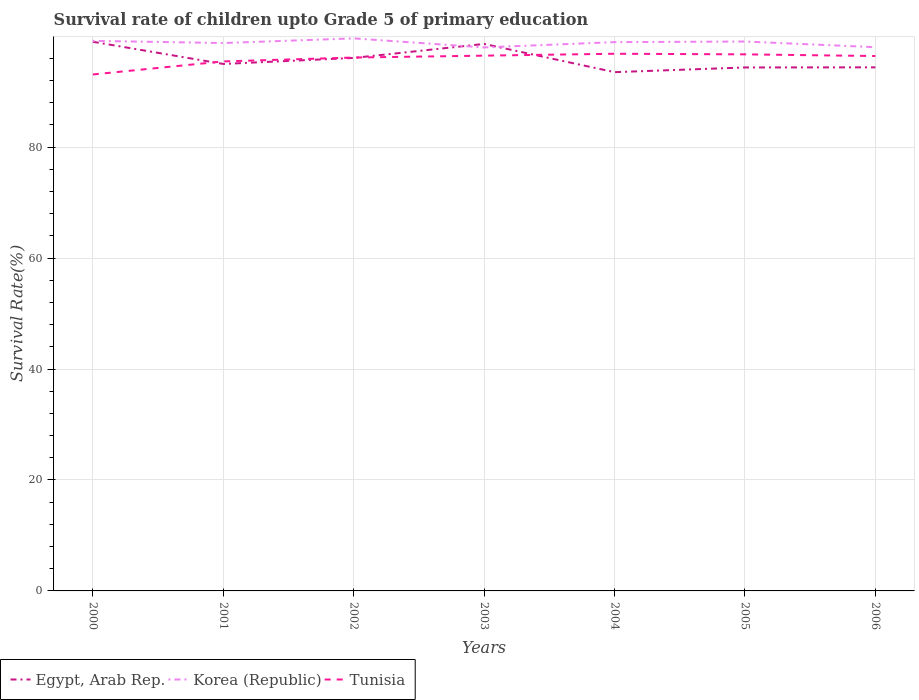Does the line corresponding to Tunisia intersect with the line corresponding to Egypt, Arab Rep.?
Give a very brief answer. Yes. Across all years, what is the maximum survival rate of children in Tunisia?
Make the answer very short. 93.1. What is the total survival rate of children in Egypt, Arab Rep. in the graph?
Make the answer very short. -0.02. What is the difference between the highest and the second highest survival rate of children in Korea (Republic)?
Ensure brevity in your answer.  1.63. What is the difference between two consecutive major ticks on the Y-axis?
Your response must be concise. 20. Does the graph contain grids?
Offer a very short reply. Yes. Where does the legend appear in the graph?
Your response must be concise. Bottom left. How many legend labels are there?
Provide a short and direct response. 3. What is the title of the graph?
Your response must be concise. Survival rate of children upto Grade 5 of primary education. What is the label or title of the Y-axis?
Offer a terse response. Survival Rate(%). What is the Survival Rate(%) of Egypt, Arab Rep. in 2000?
Your answer should be compact. 99. What is the Survival Rate(%) of Korea (Republic) in 2000?
Provide a succinct answer. 99.17. What is the Survival Rate(%) in Tunisia in 2000?
Your answer should be very brief. 93.1. What is the Survival Rate(%) of Egypt, Arab Rep. in 2001?
Provide a short and direct response. 95. What is the Survival Rate(%) of Korea (Republic) in 2001?
Give a very brief answer. 98.77. What is the Survival Rate(%) in Tunisia in 2001?
Your response must be concise. 95.46. What is the Survival Rate(%) of Egypt, Arab Rep. in 2002?
Make the answer very short. 96.09. What is the Survival Rate(%) in Korea (Republic) in 2002?
Keep it short and to the point. 99.61. What is the Survival Rate(%) in Tunisia in 2002?
Ensure brevity in your answer.  96.15. What is the Survival Rate(%) of Egypt, Arab Rep. in 2003?
Offer a terse response. 98.6. What is the Survival Rate(%) of Korea (Republic) in 2003?
Provide a short and direct response. 97.98. What is the Survival Rate(%) of Tunisia in 2003?
Keep it short and to the point. 96.49. What is the Survival Rate(%) of Egypt, Arab Rep. in 2004?
Your response must be concise. 93.52. What is the Survival Rate(%) in Korea (Republic) in 2004?
Keep it short and to the point. 98.93. What is the Survival Rate(%) in Tunisia in 2004?
Offer a terse response. 96.84. What is the Survival Rate(%) of Egypt, Arab Rep. in 2005?
Your response must be concise. 94.37. What is the Survival Rate(%) in Korea (Republic) in 2005?
Offer a very short reply. 99.04. What is the Survival Rate(%) of Tunisia in 2005?
Make the answer very short. 96.73. What is the Survival Rate(%) in Egypt, Arab Rep. in 2006?
Give a very brief answer. 94.39. What is the Survival Rate(%) in Korea (Republic) in 2006?
Give a very brief answer. 98.02. What is the Survival Rate(%) in Tunisia in 2006?
Offer a very short reply. 96.43. Across all years, what is the maximum Survival Rate(%) in Egypt, Arab Rep.?
Provide a short and direct response. 99. Across all years, what is the maximum Survival Rate(%) in Korea (Republic)?
Provide a short and direct response. 99.61. Across all years, what is the maximum Survival Rate(%) of Tunisia?
Keep it short and to the point. 96.84. Across all years, what is the minimum Survival Rate(%) of Egypt, Arab Rep.?
Keep it short and to the point. 93.52. Across all years, what is the minimum Survival Rate(%) in Korea (Republic)?
Give a very brief answer. 97.98. Across all years, what is the minimum Survival Rate(%) of Tunisia?
Make the answer very short. 93.1. What is the total Survival Rate(%) of Egypt, Arab Rep. in the graph?
Offer a very short reply. 670.96. What is the total Survival Rate(%) of Korea (Republic) in the graph?
Your answer should be very brief. 691.51. What is the total Survival Rate(%) of Tunisia in the graph?
Offer a very short reply. 671.2. What is the difference between the Survival Rate(%) of Egypt, Arab Rep. in 2000 and that in 2001?
Give a very brief answer. 4. What is the difference between the Survival Rate(%) in Korea (Republic) in 2000 and that in 2001?
Keep it short and to the point. 0.4. What is the difference between the Survival Rate(%) in Tunisia in 2000 and that in 2001?
Your answer should be very brief. -2.35. What is the difference between the Survival Rate(%) in Egypt, Arab Rep. in 2000 and that in 2002?
Your answer should be compact. 2.91. What is the difference between the Survival Rate(%) in Korea (Republic) in 2000 and that in 2002?
Your answer should be very brief. -0.44. What is the difference between the Survival Rate(%) of Tunisia in 2000 and that in 2002?
Make the answer very short. -3.05. What is the difference between the Survival Rate(%) in Egypt, Arab Rep. in 2000 and that in 2003?
Offer a very short reply. 0.4. What is the difference between the Survival Rate(%) of Korea (Republic) in 2000 and that in 2003?
Provide a succinct answer. 1.19. What is the difference between the Survival Rate(%) in Tunisia in 2000 and that in 2003?
Offer a very short reply. -3.39. What is the difference between the Survival Rate(%) of Egypt, Arab Rep. in 2000 and that in 2004?
Provide a short and direct response. 5.48. What is the difference between the Survival Rate(%) of Korea (Republic) in 2000 and that in 2004?
Your response must be concise. 0.23. What is the difference between the Survival Rate(%) of Tunisia in 2000 and that in 2004?
Provide a short and direct response. -3.73. What is the difference between the Survival Rate(%) in Egypt, Arab Rep. in 2000 and that in 2005?
Offer a terse response. 4.63. What is the difference between the Survival Rate(%) in Korea (Republic) in 2000 and that in 2005?
Your response must be concise. 0.12. What is the difference between the Survival Rate(%) of Tunisia in 2000 and that in 2005?
Your answer should be very brief. -3.63. What is the difference between the Survival Rate(%) of Egypt, Arab Rep. in 2000 and that in 2006?
Keep it short and to the point. 4.61. What is the difference between the Survival Rate(%) in Korea (Republic) in 2000 and that in 2006?
Offer a terse response. 1.15. What is the difference between the Survival Rate(%) of Tunisia in 2000 and that in 2006?
Your response must be concise. -3.32. What is the difference between the Survival Rate(%) of Egypt, Arab Rep. in 2001 and that in 2002?
Offer a very short reply. -1.09. What is the difference between the Survival Rate(%) of Korea (Republic) in 2001 and that in 2002?
Keep it short and to the point. -0.84. What is the difference between the Survival Rate(%) in Tunisia in 2001 and that in 2002?
Offer a terse response. -0.7. What is the difference between the Survival Rate(%) in Egypt, Arab Rep. in 2001 and that in 2003?
Your answer should be very brief. -3.6. What is the difference between the Survival Rate(%) in Korea (Republic) in 2001 and that in 2003?
Provide a short and direct response. 0.79. What is the difference between the Survival Rate(%) of Tunisia in 2001 and that in 2003?
Offer a very short reply. -1.04. What is the difference between the Survival Rate(%) of Egypt, Arab Rep. in 2001 and that in 2004?
Make the answer very short. 1.48. What is the difference between the Survival Rate(%) of Korea (Republic) in 2001 and that in 2004?
Give a very brief answer. -0.16. What is the difference between the Survival Rate(%) of Tunisia in 2001 and that in 2004?
Ensure brevity in your answer.  -1.38. What is the difference between the Survival Rate(%) in Egypt, Arab Rep. in 2001 and that in 2005?
Offer a terse response. 0.63. What is the difference between the Survival Rate(%) of Korea (Republic) in 2001 and that in 2005?
Your answer should be very brief. -0.27. What is the difference between the Survival Rate(%) in Tunisia in 2001 and that in 2005?
Give a very brief answer. -1.27. What is the difference between the Survival Rate(%) in Egypt, Arab Rep. in 2001 and that in 2006?
Keep it short and to the point. 0.61. What is the difference between the Survival Rate(%) in Korea (Republic) in 2001 and that in 2006?
Your answer should be compact. 0.75. What is the difference between the Survival Rate(%) in Tunisia in 2001 and that in 2006?
Give a very brief answer. -0.97. What is the difference between the Survival Rate(%) in Egypt, Arab Rep. in 2002 and that in 2003?
Make the answer very short. -2.52. What is the difference between the Survival Rate(%) in Korea (Republic) in 2002 and that in 2003?
Your response must be concise. 1.63. What is the difference between the Survival Rate(%) of Tunisia in 2002 and that in 2003?
Offer a terse response. -0.34. What is the difference between the Survival Rate(%) in Egypt, Arab Rep. in 2002 and that in 2004?
Provide a succinct answer. 2.57. What is the difference between the Survival Rate(%) of Korea (Republic) in 2002 and that in 2004?
Your response must be concise. 0.68. What is the difference between the Survival Rate(%) of Tunisia in 2002 and that in 2004?
Give a very brief answer. -0.68. What is the difference between the Survival Rate(%) in Egypt, Arab Rep. in 2002 and that in 2005?
Your answer should be very brief. 1.72. What is the difference between the Survival Rate(%) of Korea (Republic) in 2002 and that in 2005?
Ensure brevity in your answer.  0.57. What is the difference between the Survival Rate(%) in Tunisia in 2002 and that in 2005?
Make the answer very short. -0.58. What is the difference between the Survival Rate(%) of Egypt, Arab Rep. in 2002 and that in 2006?
Keep it short and to the point. 1.7. What is the difference between the Survival Rate(%) of Korea (Republic) in 2002 and that in 2006?
Ensure brevity in your answer.  1.59. What is the difference between the Survival Rate(%) in Tunisia in 2002 and that in 2006?
Offer a very short reply. -0.27. What is the difference between the Survival Rate(%) in Egypt, Arab Rep. in 2003 and that in 2004?
Keep it short and to the point. 5.08. What is the difference between the Survival Rate(%) in Korea (Republic) in 2003 and that in 2004?
Make the answer very short. -0.96. What is the difference between the Survival Rate(%) of Tunisia in 2003 and that in 2004?
Provide a succinct answer. -0.34. What is the difference between the Survival Rate(%) in Egypt, Arab Rep. in 2003 and that in 2005?
Your answer should be compact. 4.24. What is the difference between the Survival Rate(%) in Korea (Republic) in 2003 and that in 2005?
Offer a very short reply. -1.07. What is the difference between the Survival Rate(%) in Tunisia in 2003 and that in 2005?
Your response must be concise. -0.23. What is the difference between the Survival Rate(%) of Egypt, Arab Rep. in 2003 and that in 2006?
Give a very brief answer. 4.21. What is the difference between the Survival Rate(%) of Korea (Republic) in 2003 and that in 2006?
Provide a short and direct response. -0.04. What is the difference between the Survival Rate(%) of Tunisia in 2003 and that in 2006?
Your response must be concise. 0.07. What is the difference between the Survival Rate(%) in Egypt, Arab Rep. in 2004 and that in 2005?
Offer a terse response. -0.85. What is the difference between the Survival Rate(%) in Korea (Republic) in 2004 and that in 2005?
Your answer should be compact. -0.11. What is the difference between the Survival Rate(%) in Tunisia in 2004 and that in 2005?
Keep it short and to the point. 0.11. What is the difference between the Survival Rate(%) of Egypt, Arab Rep. in 2004 and that in 2006?
Your response must be concise. -0.87. What is the difference between the Survival Rate(%) in Korea (Republic) in 2004 and that in 2006?
Your response must be concise. 0.91. What is the difference between the Survival Rate(%) of Tunisia in 2004 and that in 2006?
Your answer should be compact. 0.41. What is the difference between the Survival Rate(%) of Egypt, Arab Rep. in 2005 and that in 2006?
Offer a terse response. -0.02. What is the difference between the Survival Rate(%) in Korea (Republic) in 2005 and that in 2006?
Offer a very short reply. 1.02. What is the difference between the Survival Rate(%) of Tunisia in 2005 and that in 2006?
Your response must be concise. 0.3. What is the difference between the Survival Rate(%) in Egypt, Arab Rep. in 2000 and the Survival Rate(%) in Korea (Republic) in 2001?
Ensure brevity in your answer.  0.23. What is the difference between the Survival Rate(%) in Egypt, Arab Rep. in 2000 and the Survival Rate(%) in Tunisia in 2001?
Ensure brevity in your answer.  3.54. What is the difference between the Survival Rate(%) of Korea (Republic) in 2000 and the Survival Rate(%) of Tunisia in 2001?
Your answer should be very brief. 3.71. What is the difference between the Survival Rate(%) of Egypt, Arab Rep. in 2000 and the Survival Rate(%) of Korea (Republic) in 2002?
Your answer should be compact. -0.61. What is the difference between the Survival Rate(%) of Egypt, Arab Rep. in 2000 and the Survival Rate(%) of Tunisia in 2002?
Give a very brief answer. 2.84. What is the difference between the Survival Rate(%) in Korea (Republic) in 2000 and the Survival Rate(%) in Tunisia in 2002?
Your answer should be very brief. 3.01. What is the difference between the Survival Rate(%) in Egypt, Arab Rep. in 2000 and the Survival Rate(%) in Korea (Republic) in 2003?
Your response must be concise. 1.02. What is the difference between the Survival Rate(%) in Egypt, Arab Rep. in 2000 and the Survival Rate(%) in Tunisia in 2003?
Provide a short and direct response. 2.5. What is the difference between the Survival Rate(%) in Korea (Republic) in 2000 and the Survival Rate(%) in Tunisia in 2003?
Provide a short and direct response. 2.67. What is the difference between the Survival Rate(%) in Egypt, Arab Rep. in 2000 and the Survival Rate(%) in Korea (Republic) in 2004?
Give a very brief answer. 0.07. What is the difference between the Survival Rate(%) in Egypt, Arab Rep. in 2000 and the Survival Rate(%) in Tunisia in 2004?
Provide a short and direct response. 2.16. What is the difference between the Survival Rate(%) of Korea (Republic) in 2000 and the Survival Rate(%) of Tunisia in 2004?
Your answer should be compact. 2.33. What is the difference between the Survival Rate(%) in Egypt, Arab Rep. in 2000 and the Survival Rate(%) in Korea (Republic) in 2005?
Provide a short and direct response. -0.04. What is the difference between the Survival Rate(%) in Egypt, Arab Rep. in 2000 and the Survival Rate(%) in Tunisia in 2005?
Your answer should be very brief. 2.27. What is the difference between the Survival Rate(%) of Korea (Republic) in 2000 and the Survival Rate(%) of Tunisia in 2005?
Your answer should be very brief. 2.44. What is the difference between the Survival Rate(%) in Egypt, Arab Rep. in 2000 and the Survival Rate(%) in Korea (Republic) in 2006?
Offer a terse response. 0.98. What is the difference between the Survival Rate(%) in Egypt, Arab Rep. in 2000 and the Survival Rate(%) in Tunisia in 2006?
Provide a short and direct response. 2.57. What is the difference between the Survival Rate(%) in Korea (Republic) in 2000 and the Survival Rate(%) in Tunisia in 2006?
Your answer should be very brief. 2.74. What is the difference between the Survival Rate(%) in Egypt, Arab Rep. in 2001 and the Survival Rate(%) in Korea (Republic) in 2002?
Ensure brevity in your answer.  -4.61. What is the difference between the Survival Rate(%) in Egypt, Arab Rep. in 2001 and the Survival Rate(%) in Tunisia in 2002?
Your response must be concise. -1.15. What is the difference between the Survival Rate(%) in Korea (Republic) in 2001 and the Survival Rate(%) in Tunisia in 2002?
Keep it short and to the point. 2.61. What is the difference between the Survival Rate(%) of Egypt, Arab Rep. in 2001 and the Survival Rate(%) of Korea (Republic) in 2003?
Offer a very short reply. -2.98. What is the difference between the Survival Rate(%) of Egypt, Arab Rep. in 2001 and the Survival Rate(%) of Tunisia in 2003?
Ensure brevity in your answer.  -1.5. What is the difference between the Survival Rate(%) in Korea (Republic) in 2001 and the Survival Rate(%) in Tunisia in 2003?
Provide a succinct answer. 2.27. What is the difference between the Survival Rate(%) in Egypt, Arab Rep. in 2001 and the Survival Rate(%) in Korea (Republic) in 2004?
Your answer should be compact. -3.93. What is the difference between the Survival Rate(%) of Egypt, Arab Rep. in 2001 and the Survival Rate(%) of Tunisia in 2004?
Give a very brief answer. -1.84. What is the difference between the Survival Rate(%) in Korea (Republic) in 2001 and the Survival Rate(%) in Tunisia in 2004?
Give a very brief answer. 1.93. What is the difference between the Survival Rate(%) in Egypt, Arab Rep. in 2001 and the Survival Rate(%) in Korea (Republic) in 2005?
Your response must be concise. -4.04. What is the difference between the Survival Rate(%) in Egypt, Arab Rep. in 2001 and the Survival Rate(%) in Tunisia in 2005?
Give a very brief answer. -1.73. What is the difference between the Survival Rate(%) of Korea (Republic) in 2001 and the Survival Rate(%) of Tunisia in 2005?
Ensure brevity in your answer.  2.04. What is the difference between the Survival Rate(%) in Egypt, Arab Rep. in 2001 and the Survival Rate(%) in Korea (Republic) in 2006?
Give a very brief answer. -3.02. What is the difference between the Survival Rate(%) in Egypt, Arab Rep. in 2001 and the Survival Rate(%) in Tunisia in 2006?
Your response must be concise. -1.43. What is the difference between the Survival Rate(%) in Korea (Republic) in 2001 and the Survival Rate(%) in Tunisia in 2006?
Provide a succinct answer. 2.34. What is the difference between the Survival Rate(%) of Egypt, Arab Rep. in 2002 and the Survival Rate(%) of Korea (Republic) in 2003?
Ensure brevity in your answer.  -1.89. What is the difference between the Survival Rate(%) of Egypt, Arab Rep. in 2002 and the Survival Rate(%) of Tunisia in 2003?
Ensure brevity in your answer.  -0.41. What is the difference between the Survival Rate(%) in Korea (Republic) in 2002 and the Survival Rate(%) in Tunisia in 2003?
Provide a short and direct response. 3.11. What is the difference between the Survival Rate(%) in Egypt, Arab Rep. in 2002 and the Survival Rate(%) in Korea (Republic) in 2004?
Your answer should be compact. -2.84. What is the difference between the Survival Rate(%) in Egypt, Arab Rep. in 2002 and the Survival Rate(%) in Tunisia in 2004?
Offer a terse response. -0.75. What is the difference between the Survival Rate(%) of Korea (Republic) in 2002 and the Survival Rate(%) of Tunisia in 2004?
Keep it short and to the point. 2.77. What is the difference between the Survival Rate(%) of Egypt, Arab Rep. in 2002 and the Survival Rate(%) of Korea (Republic) in 2005?
Offer a very short reply. -2.96. What is the difference between the Survival Rate(%) in Egypt, Arab Rep. in 2002 and the Survival Rate(%) in Tunisia in 2005?
Your answer should be compact. -0.64. What is the difference between the Survival Rate(%) in Korea (Republic) in 2002 and the Survival Rate(%) in Tunisia in 2005?
Your response must be concise. 2.88. What is the difference between the Survival Rate(%) in Egypt, Arab Rep. in 2002 and the Survival Rate(%) in Korea (Republic) in 2006?
Ensure brevity in your answer.  -1.93. What is the difference between the Survival Rate(%) of Egypt, Arab Rep. in 2002 and the Survival Rate(%) of Tunisia in 2006?
Provide a succinct answer. -0.34. What is the difference between the Survival Rate(%) in Korea (Republic) in 2002 and the Survival Rate(%) in Tunisia in 2006?
Your answer should be compact. 3.18. What is the difference between the Survival Rate(%) in Egypt, Arab Rep. in 2003 and the Survival Rate(%) in Korea (Republic) in 2004?
Offer a terse response. -0.33. What is the difference between the Survival Rate(%) of Egypt, Arab Rep. in 2003 and the Survival Rate(%) of Tunisia in 2004?
Offer a terse response. 1.77. What is the difference between the Survival Rate(%) in Korea (Republic) in 2003 and the Survival Rate(%) in Tunisia in 2004?
Make the answer very short. 1.14. What is the difference between the Survival Rate(%) of Egypt, Arab Rep. in 2003 and the Survival Rate(%) of Korea (Republic) in 2005?
Offer a terse response. -0.44. What is the difference between the Survival Rate(%) of Egypt, Arab Rep. in 2003 and the Survival Rate(%) of Tunisia in 2005?
Offer a very short reply. 1.87. What is the difference between the Survival Rate(%) of Korea (Republic) in 2003 and the Survival Rate(%) of Tunisia in 2005?
Your answer should be very brief. 1.25. What is the difference between the Survival Rate(%) of Egypt, Arab Rep. in 2003 and the Survival Rate(%) of Korea (Republic) in 2006?
Keep it short and to the point. 0.58. What is the difference between the Survival Rate(%) of Egypt, Arab Rep. in 2003 and the Survival Rate(%) of Tunisia in 2006?
Provide a short and direct response. 2.18. What is the difference between the Survival Rate(%) in Korea (Republic) in 2003 and the Survival Rate(%) in Tunisia in 2006?
Offer a terse response. 1.55. What is the difference between the Survival Rate(%) of Egypt, Arab Rep. in 2004 and the Survival Rate(%) of Korea (Republic) in 2005?
Give a very brief answer. -5.52. What is the difference between the Survival Rate(%) of Egypt, Arab Rep. in 2004 and the Survival Rate(%) of Tunisia in 2005?
Keep it short and to the point. -3.21. What is the difference between the Survival Rate(%) in Korea (Republic) in 2004 and the Survival Rate(%) in Tunisia in 2005?
Provide a short and direct response. 2.2. What is the difference between the Survival Rate(%) in Egypt, Arab Rep. in 2004 and the Survival Rate(%) in Korea (Republic) in 2006?
Provide a succinct answer. -4.5. What is the difference between the Survival Rate(%) of Egypt, Arab Rep. in 2004 and the Survival Rate(%) of Tunisia in 2006?
Make the answer very short. -2.91. What is the difference between the Survival Rate(%) of Korea (Republic) in 2004 and the Survival Rate(%) of Tunisia in 2006?
Make the answer very short. 2.5. What is the difference between the Survival Rate(%) of Egypt, Arab Rep. in 2005 and the Survival Rate(%) of Korea (Republic) in 2006?
Ensure brevity in your answer.  -3.65. What is the difference between the Survival Rate(%) of Egypt, Arab Rep. in 2005 and the Survival Rate(%) of Tunisia in 2006?
Keep it short and to the point. -2.06. What is the difference between the Survival Rate(%) in Korea (Republic) in 2005 and the Survival Rate(%) in Tunisia in 2006?
Provide a short and direct response. 2.62. What is the average Survival Rate(%) of Egypt, Arab Rep. per year?
Offer a very short reply. 95.85. What is the average Survival Rate(%) of Korea (Republic) per year?
Offer a very short reply. 98.79. What is the average Survival Rate(%) of Tunisia per year?
Provide a succinct answer. 95.89. In the year 2000, what is the difference between the Survival Rate(%) of Egypt, Arab Rep. and Survival Rate(%) of Korea (Republic)?
Ensure brevity in your answer.  -0.17. In the year 2000, what is the difference between the Survival Rate(%) of Egypt, Arab Rep. and Survival Rate(%) of Tunisia?
Your answer should be compact. 5.9. In the year 2000, what is the difference between the Survival Rate(%) in Korea (Republic) and Survival Rate(%) in Tunisia?
Your response must be concise. 6.06. In the year 2001, what is the difference between the Survival Rate(%) of Egypt, Arab Rep. and Survival Rate(%) of Korea (Republic)?
Offer a terse response. -3.77. In the year 2001, what is the difference between the Survival Rate(%) of Egypt, Arab Rep. and Survival Rate(%) of Tunisia?
Offer a terse response. -0.46. In the year 2001, what is the difference between the Survival Rate(%) of Korea (Republic) and Survival Rate(%) of Tunisia?
Give a very brief answer. 3.31. In the year 2002, what is the difference between the Survival Rate(%) of Egypt, Arab Rep. and Survival Rate(%) of Korea (Republic)?
Offer a terse response. -3.52. In the year 2002, what is the difference between the Survival Rate(%) in Egypt, Arab Rep. and Survival Rate(%) in Tunisia?
Your answer should be compact. -0.07. In the year 2002, what is the difference between the Survival Rate(%) of Korea (Republic) and Survival Rate(%) of Tunisia?
Make the answer very short. 3.45. In the year 2003, what is the difference between the Survival Rate(%) in Egypt, Arab Rep. and Survival Rate(%) in Korea (Republic)?
Make the answer very short. 0.63. In the year 2003, what is the difference between the Survival Rate(%) of Egypt, Arab Rep. and Survival Rate(%) of Tunisia?
Your answer should be very brief. 2.11. In the year 2003, what is the difference between the Survival Rate(%) of Korea (Republic) and Survival Rate(%) of Tunisia?
Ensure brevity in your answer.  1.48. In the year 2004, what is the difference between the Survival Rate(%) of Egypt, Arab Rep. and Survival Rate(%) of Korea (Republic)?
Ensure brevity in your answer.  -5.41. In the year 2004, what is the difference between the Survival Rate(%) of Egypt, Arab Rep. and Survival Rate(%) of Tunisia?
Your response must be concise. -3.32. In the year 2004, what is the difference between the Survival Rate(%) of Korea (Republic) and Survival Rate(%) of Tunisia?
Offer a very short reply. 2.09. In the year 2005, what is the difference between the Survival Rate(%) in Egypt, Arab Rep. and Survival Rate(%) in Korea (Republic)?
Ensure brevity in your answer.  -4.68. In the year 2005, what is the difference between the Survival Rate(%) in Egypt, Arab Rep. and Survival Rate(%) in Tunisia?
Your answer should be compact. -2.36. In the year 2005, what is the difference between the Survival Rate(%) in Korea (Republic) and Survival Rate(%) in Tunisia?
Offer a terse response. 2.31. In the year 2006, what is the difference between the Survival Rate(%) of Egypt, Arab Rep. and Survival Rate(%) of Korea (Republic)?
Provide a succinct answer. -3.63. In the year 2006, what is the difference between the Survival Rate(%) in Egypt, Arab Rep. and Survival Rate(%) in Tunisia?
Your answer should be compact. -2.04. In the year 2006, what is the difference between the Survival Rate(%) of Korea (Republic) and Survival Rate(%) of Tunisia?
Offer a very short reply. 1.59. What is the ratio of the Survival Rate(%) of Egypt, Arab Rep. in 2000 to that in 2001?
Make the answer very short. 1.04. What is the ratio of the Survival Rate(%) of Korea (Republic) in 2000 to that in 2001?
Provide a succinct answer. 1. What is the ratio of the Survival Rate(%) in Tunisia in 2000 to that in 2001?
Your answer should be very brief. 0.98. What is the ratio of the Survival Rate(%) of Egypt, Arab Rep. in 2000 to that in 2002?
Keep it short and to the point. 1.03. What is the ratio of the Survival Rate(%) in Korea (Republic) in 2000 to that in 2002?
Offer a very short reply. 1. What is the ratio of the Survival Rate(%) in Tunisia in 2000 to that in 2002?
Offer a very short reply. 0.97. What is the ratio of the Survival Rate(%) in Egypt, Arab Rep. in 2000 to that in 2003?
Keep it short and to the point. 1. What is the ratio of the Survival Rate(%) in Korea (Republic) in 2000 to that in 2003?
Provide a short and direct response. 1.01. What is the ratio of the Survival Rate(%) in Tunisia in 2000 to that in 2003?
Make the answer very short. 0.96. What is the ratio of the Survival Rate(%) in Egypt, Arab Rep. in 2000 to that in 2004?
Your response must be concise. 1.06. What is the ratio of the Survival Rate(%) in Tunisia in 2000 to that in 2004?
Keep it short and to the point. 0.96. What is the ratio of the Survival Rate(%) in Egypt, Arab Rep. in 2000 to that in 2005?
Make the answer very short. 1.05. What is the ratio of the Survival Rate(%) of Korea (Republic) in 2000 to that in 2005?
Your answer should be very brief. 1. What is the ratio of the Survival Rate(%) in Tunisia in 2000 to that in 2005?
Provide a succinct answer. 0.96. What is the ratio of the Survival Rate(%) in Egypt, Arab Rep. in 2000 to that in 2006?
Your response must be concise. 1.05. What is the ratio of the Survival Rate(%) of Korea (Republic) in 2000 to that in 2006?
Provide a succinct answer. 1.01. What is the ratio of the Survival Rate(%) in Tunisia in 2000 to that in 2006?
Your answer should be very brief. 0.97. What is the ratio of the Survival Rate(%) of Egypt, Arab Rep. in 2001 to that in 2002?
Offer a very short reply. 0.99. What is the ratio of the Survival Rate(%) in Korea (Republic) in 2001 to that in 2002?
Offer a terse response. 0.99. What is the ratio of the Survival Rate(%) in Tunisia in 2001 to that in 2002?
Make the answer very short. 0.99. What is the ratio of the Survival Rate(%) of Egypt, Arab Rep. in 2001 to that in 2003?
Your answer should be very brief. 0.96. What is the ratio of the Survival Rate(%) in Korea (Republic) in 2001 to that in 2003?
Give a very brief answer. 1.01. What is the ratio of the Survival Rate(%) in Tunisia in 2001 to that in 2003?
Keep it short and to the point. 0.99. What is the ratio of the Survival Rate(%) in Egypt, Arab Rep. in 2001 to that in 2004?
Offer a terse response. 1.02. What is the ratio of the Survival Rate(%) in Korea (Republic) in 2001 to that in 2004?
Your response must be concise. 1. What is the ratio of the Survival Rate(%) in Tunisia in 2001 to that in 2004?
Keep it short and to the point. 0.99. What is the ratio of the Survival Rate(%) of Korea (Republic) in 2001 to that in 2006?
Your answer should be compact. 1.01. What is the ratio of the Survival Rate(%) in Egypt, Arab Rep. in 2002 to that in 2003?
Ensure brevity in your answer.  0.97. What is the ratio of the Survival Rate(%) in Korea (Republic) in 2002 to that in 2003?
Provide a short and direct response. 1.02. What is the ratio of the Survival Rate(%) in Egypt, Arab Rep. in 2002 to that in 2004?
Keep it short and to the point. 1.03. What is the ratio of the Survival Rate(%) of Korea (Republic) in 2002 to that in 2004?
Ensure brevity in your answer.  1.01. What is the ratio of the Survival Rate(%) of Egypt, Arab Rep. in 2002 to that in 2005?
Ensure brevity in your answer.  1.02. What is the ratio of the Survival Rate(%) of Egypt, Arab Rep. in 2002 to that in 2006?
Offer a terse response. 1.02. What is the ratio of the Survival Rate(%) of Korea (Republic) in 2002 to that in 2006?
Offer a terse response. 1.02. What is the ratio of the Survival Rate(%) of Tunisia in 2002 to that in 2006?
Provide a succinct answer. 1. What is the ratio of the Survival Rate(%) in Egypt, Arab Rep. in 2003 to that in 2004?
Your answer should be very brief. 1.05. What is the ratio of the Survival Rate(%) of Korea (Republic) in 2003 to that in 2004?
Give a very brief answer. 0.99. What is the ratio of the Survival Rate(%) of Tunisia in 2003 to that in 2004?
Offer a terse response. 1. What is the ratio of the Survival Rate(%) of Egypt, Arab Rep. in 2003 to that in 2005?
Ensure brevity in your answer.  1.04. What is the ratio of the Survival Rate(%) in Egypt, Arab Rep. in 2003 to that in 2006?
Your response must be concise. 1.04. What is the ratio of the Survival Rate(%) of Egypt, Arab Rep. in 2004 to that in 2005?
Offer a very short reply. 0.99. What is the ratio of the Survival Rate(%) of Korea (Republic) in 2004 to that in 2005?
Ensure brevity in your answer.  1. What is the ratio of the Survival Rate(%) of Tunisia in 2004 to that in 2005?
Offer a very short reply. 1. What is the ratio of the Survival Rate(%) in Korea (Republic) in 2004 to that in 2006?
Keep it short and to the point. 1.01. What is the ratio of the Survival Rate(%) in Tunisia in 2004 to that in 2006?
Provide a succinct answer. 1. What is the ratio of the Survival Rate(%) in Egypt, Arab Rep. in 2005 to that in 2006?
Your response must be concise. 1. What is the ratio of the Survival Rate(%) of Korea (Republic) in 2005 to that in 2006?
Your answer should be compact. 1.01. What is the ratio of the Survival Rate(%) of Tunisia in 2005 to that in 2006?
Offer a very short reply. 1. What is the difference between the highest and the second highest Survival Rate(%) in Egypt, Arab Rep.?
Offer a very short reply. 0.4. What is the difference between the highest and the second highest Survival Rate(%) of Korea (Republic)?
Your response must be concise. 0.44. What is the difference between the highest and the second highest Survival Rate(%) of Tunisia?
Your answer should be compact. 0.11. What is the difference between the highest and the lowest Survival Rate(%) in Egypt, Arab Rep.?
Your response must be concise. 5.48. What is the difference between the highest and the lowest Survival Rate(%) in Korea (Republic)?
Ensure brevity in your answer.  1.63. What is the difference between the highest and the lowest Survival Rate(%) of Tunisia?
Make the answer very short. 3.73. 